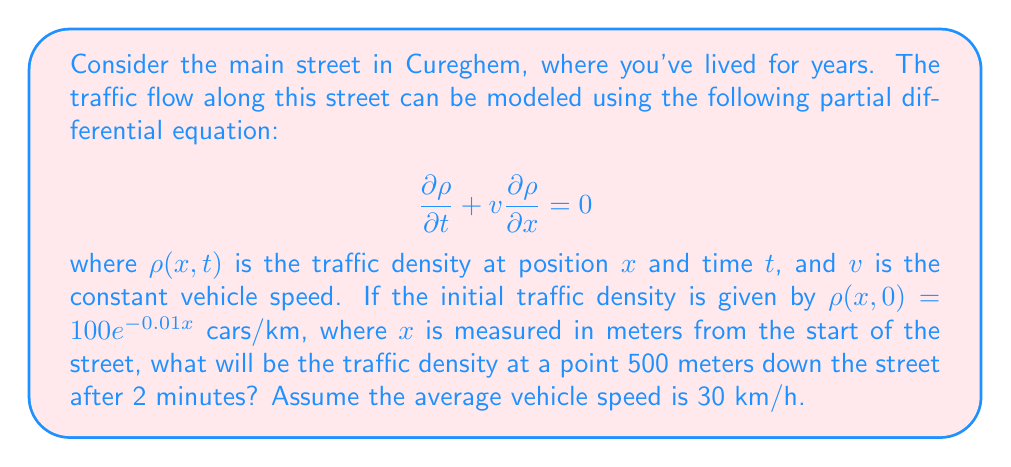Can you solve this math problem? Let's approach this step-by-step:

1) The given equation is a first-order linear partial differential equation, also known as the advection equation. Its general solution is:

   $$\rho(x,t) = f(x - vt)$$

   where $f$ is determined by the initial condition.

2) From the initial condition, we can see that $f(x) = 100e^{-0.01x}$.

3) Therefore, the solution is:

   $$\rho(x,t) = 100e^{-0.01(x - vt)}$$

4) We need to convert the given speed to m/min:
   
   $$v = 30 \text{ km/h} = 500 \text{ m/min}$$

5) Now, we can substitute the values:
   $x = 500 \text{ m}$
   $t = 2 \text{ min}$
   $v = 500 \text{ m/min}$

6) Plugging these into our solution:

   $$\rho(500, 2) = 100e^{-0.01(500 - 500 \cdot 2)}$$
   $$= 100e^{-0.01(-500)}$$
   $$= 100e^{5}$$

7) Calculating this value:

   $$100e^{5} \approx 14841.32 \text{ cars/km}$$
Answer: $14841.32$ cars/km 